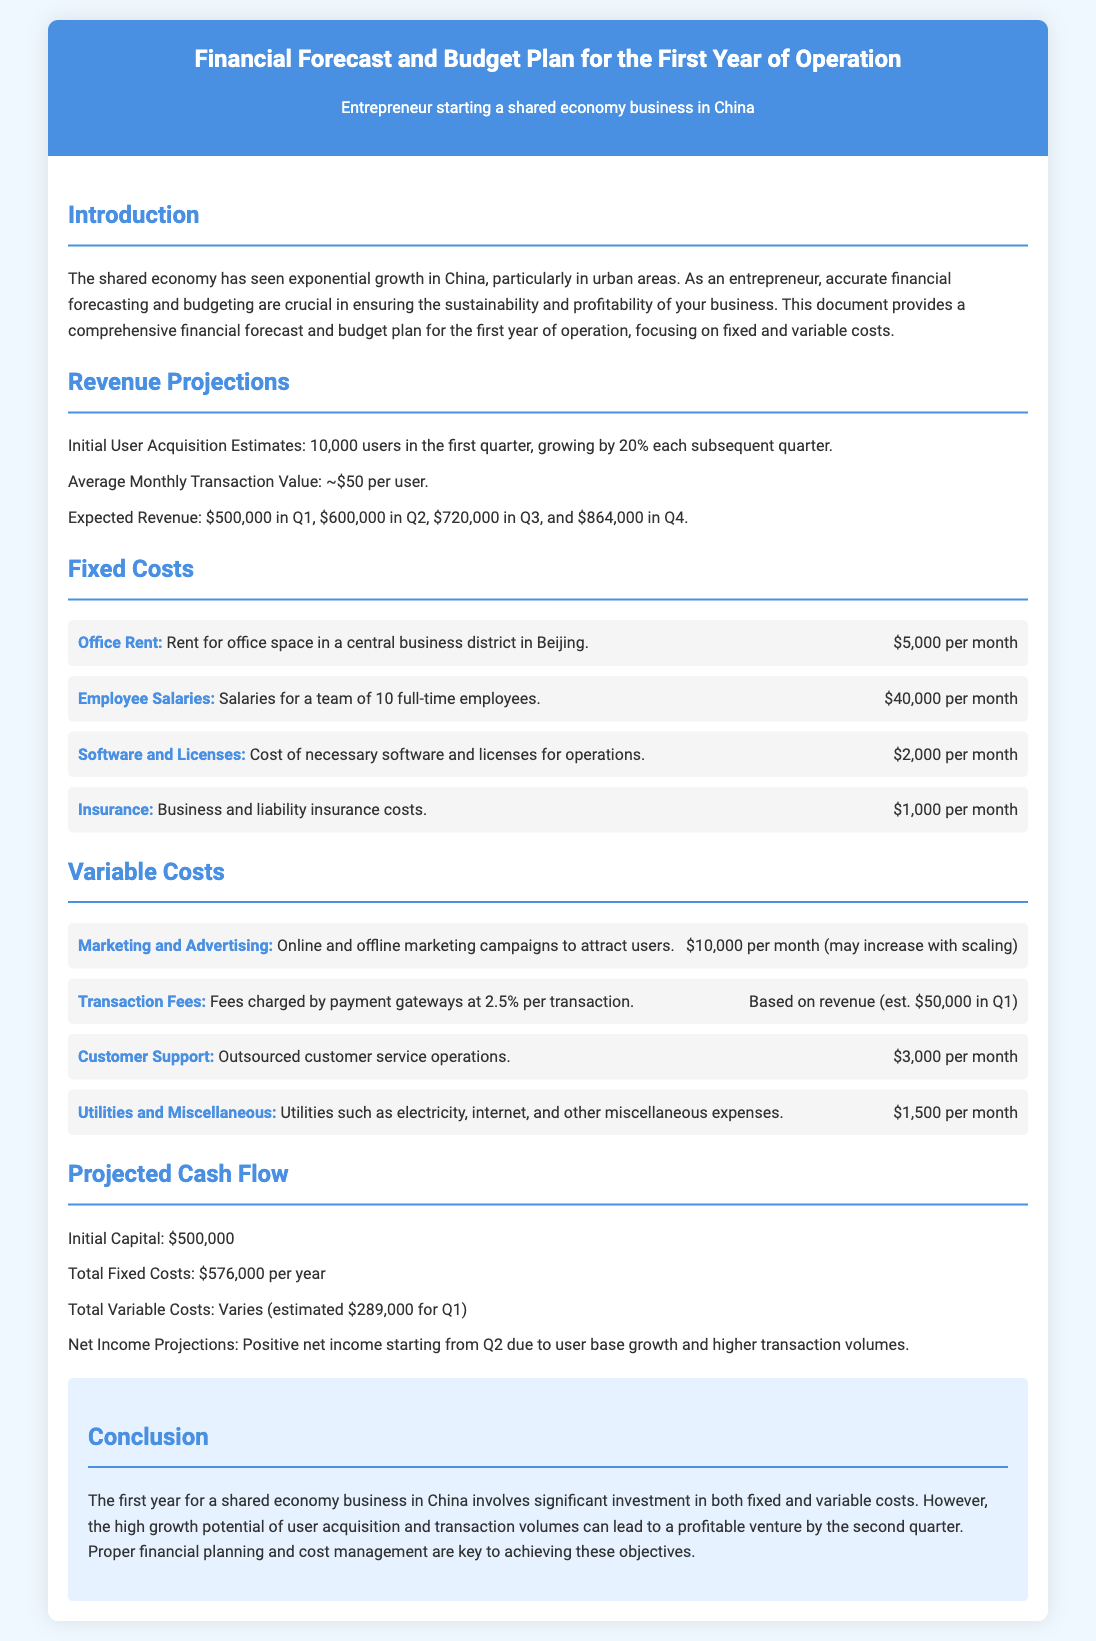what is the average monthly transaction value per user? The document states the average monthly transaction value is approximately $50 per user.
Answer: $50 how many users are expected in the first quarter? The document mentions an initial user acquisition estimate of 10,000 users in the first quarter.
Answer: 10,000 users what is the monthly cost of office rent? The fixed costs section indicates that the office rent is $5,000 per month.
Answer: $5,000 what is the total fixed costs for the year? According to the document, the total fixed costs amount to $576,000 per year.
Answer: $576,000 what is the expected revenue for Q3? The document lists the expected revenue for Q3 as $720,000.
Answer: $720,000 how much is allocated monthly for marketing and advertising? The variable costs section states that marketing and advertising costs are $10,000 per month.
Answer: $10,000 how many full-time employees are there? The fixed costs section specifies that there are a team of 10 full-time employees.
Answer: 10 what is the initial capital stated in the document? The projected cash flow section mentions the initial capital is $500,000.
Answer: $500,000 when does the document predict positive net income will start? The document states that positive net income is projected to begin in Q2.
Answer: Q2 